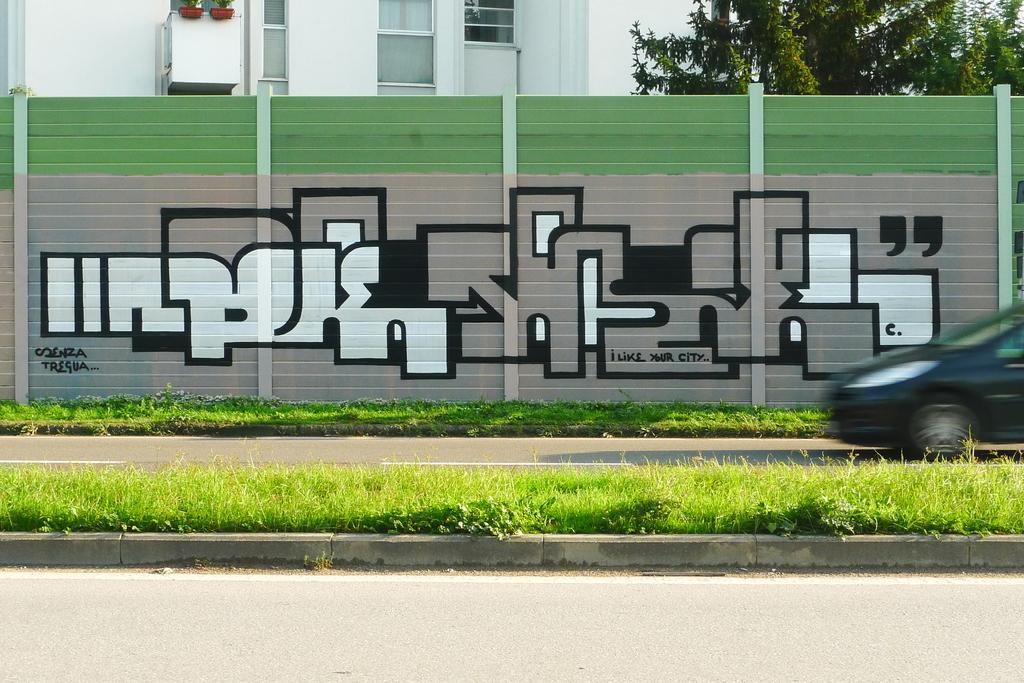Please provide a concise description of this image. In this picture we can see some grass and a vehicle on the road. There is some text and a few things on an object. We can see flower pots, glass objects and windows on the building. There are a few trees and the sky. 